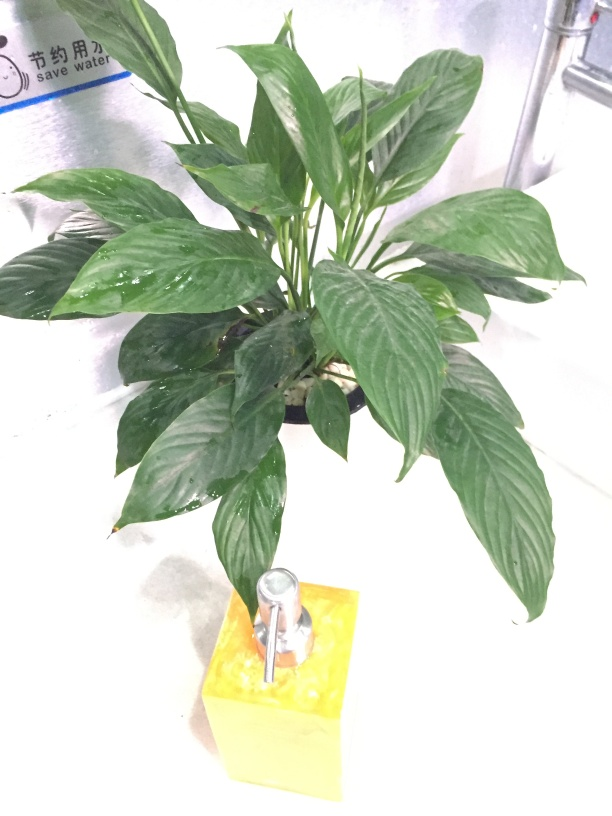Are the colors monotonous? The image portrays a plant with varying shades of green on its leaves, suggesting some degree of visual variety, though the overall color palette is limited. The green of the plant's leaves is set against a pale background, and there's a contrasting yellow object with a metallic faucet at the base. While the scene doesn't burst with color, the subtle differences in the green hues along with the yellow and metallic elements provide a modest level of chromatic diversity. 